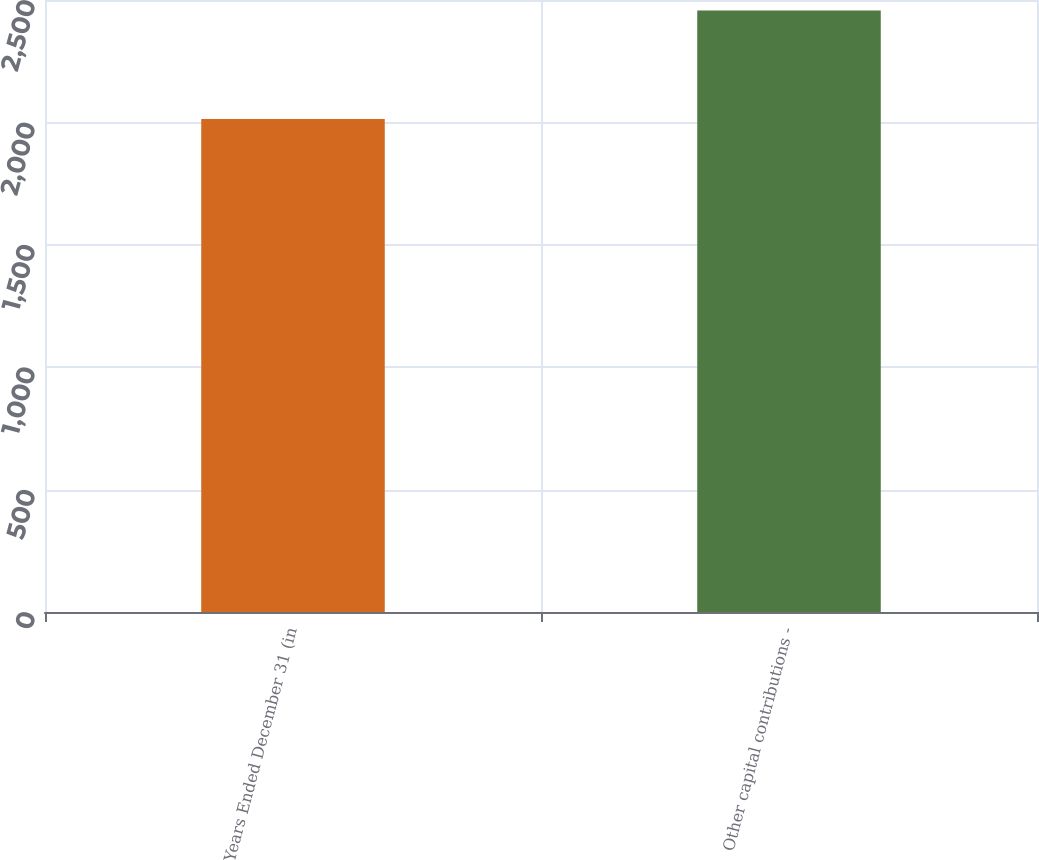Convert chart to OTSL. <chart><loc_0><loc_0><loc_500><loc_500><bar_chart><fcel>Years Ended December 31 (in<fcel>Other capital contributions -<nl><fcel>2014<fcel>2457<nl></chart> 